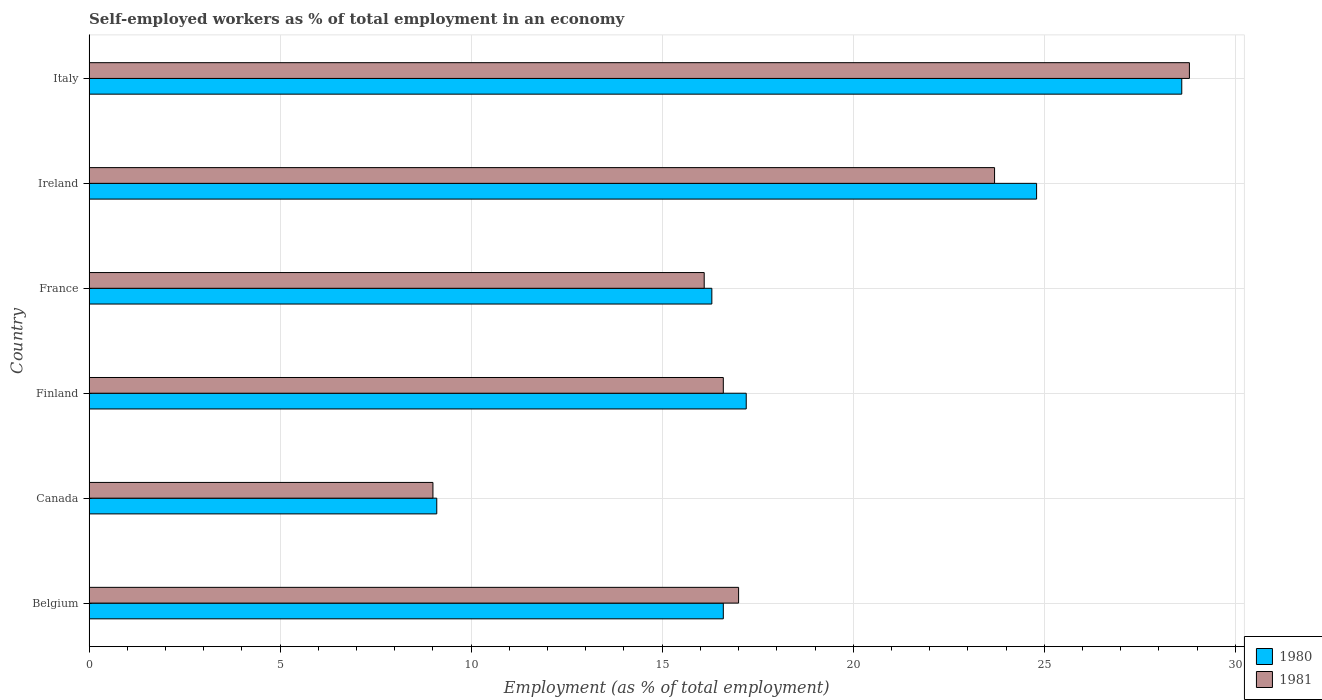How many groups of bars are there?
Give a very brief answer. 6. How many bars are there on the 6th tick from the bottom?
Ensure brevity in your answer.  2. What is the label of the 6th group of bars from the top?
Offer a very short reply. Belgium. What is the percentage of self-employed workers in 1981 in Italy?
Provide a short and direct response. 28.8. Across all countries, what is the maximum percentage of self-employed workers in 1981?
Your answer should be very brief. 28.8. Across all countries, what is the minimum percentage of self-employed workers in 1980?
Ensure brevity in your answer.  9.1. What is the total percentage of self-employed workers in 1981 in the graph?
Provide a short and direct response. 111.2. What is the difference between the percentage of self-employed workers in 1981 in Finland and that in Italy?
Your answer should be compact. -12.2. What is the difference between the percentage of self-employed workers in 1981 in Italy and the percentage of self-employed workers in 1980 in Canada?
Offer a very short reply. 19.7. What is the average percentage of self-employed workers in 1980 per country?
Keep it short and to the point. 18.77. What is the difference between the percentage of self-employed workers in 1981 and percentage of self-employed workers in 1980 in Finland?
Make the answer very short. -0.6. In how many countries, is the percentage of self-employed workers in 1980 greater than 11 %?
Offer a very short reply. 5. What is the ratio of the percentage of self-employed workers in 1981 in Finland to that in Ireland?
Offer a terse response. 0.7. Is the difference between the percentage of self-employed workers in 1981 in Belgium and Italy greater than the difference between the percentage of self-employed workers in 1980 in Belgium and Italy?
Your response must be concise. Yes. What is the difference between the highest and the second highest percentage of self-employed workers in 1981?
Provide a short and direct response. 5.1. What is the difference between the highest and the lowest percentage of self-employed workers in 1980?
Your response must be concise. 19.5. Is the sum of the percentage of self-employed workers in 1980 in Canada and France greater than the maximum percentage of self-employed workers in 1981 across all countries?
Ensure brevity in your answer.  No. What does the 1st bar from the bottom in Italy represents?
Provide a short and direct response. 1980. How many bars are there?
Keep it short and to the point. 12. Are the values on the major ticks of X-axis written in scientific E-notation?
Your response must be concise. No. Does the graph contain any zero values?
Your answer should be very brief. No. Does the graph contain grids?
Provide a succinct answer. Yes. Where does the legend appear in the graph?
Provide a short and direct response. Bottom right. How are the legend labels stacked?
Give a very brief answer. Vertical. What is the title of the graph?
Offer a terse response. Self-employed workers as % of total employment in an economy. What is the label or title of the X-axis?
Your answer should be very brief. Employment (as % of total employment). What is the Employment (as % of total employment) of 1980 in Belgium?
Offer a very short reply. 16.6. What is the Employment (as % of total employment) of 1981 in Belgium?
Make the answer very short. 17. What is the Employment (as % of total employment) of 1980 in Canada?
Your response must be concise. 9.1. What is the Employment (as % of total employment) in 1981 in Canada?
Give a very brief answer. 9. What is the Employment (as % of total employment) in 1980 in Finland?
Provide a succinct answer. 17.2. What is the Employment (as % of total employment) of 1981 in Finland?
Offer a very short reply. 16.6. What is the Employment (as % of total employment) of 1980 in France?
Your response must be concise. 16.3. What is the Employment (as % of total employment) in 1981 in France?
Your answer should be very brief. 16.1. What is the Employment (as % of total employment) of 1980 in Ireland?
Keep it short and to the point. 24.8. What is the Employment (as % of total employment) of 1981 in Ireland?
Ensure brevity in your answer.  23.7. What is the Employment (as % of total employment) in 1980 in Italy?
Provide a short and direct response. 28.6. What is the Employment (as % of total employment) in 1981 in Italy?
Ensure brevity in your answer.  28.8. Across all countries, what is the maximum Employment (as % of total employment) of 1980?
Offer a very short reply. 28.6. Across all countries, what is the maximum Employment (as % of total employment) in 1981?
Your response must be concise. 28.8. Across all countries, what is the minimum Employment (as % of total employment) of 1980?
Your answer should be very brief. 9.1. What is the total Employment (as % of total employment) in 1980 in the graph?
Provide a short and direct response. 112.6. What is the total Employment (as % of total employment) in 1981 in the graph?
Provide a short and direct response. 111.2. What is the difference between the Employment (as % of total employment) in 1980 in Belgium and that in Canada?
Make the answer very short. 7.5. What is the difference between the Employment (as % of total employment) in 1981 in Belgium and that in Canada?
Provide a succinct answer. 8. What is the difference between the Employment (as % of total employment) of 1980 in Belgium and that in Finland?
Give a very brief answer. -0.6. What is the difference between the Employment (as % of total employment) in 1980 in Belgium and that in France?
Ensure brevity in your answer.  0.3. What is the difference between the Employment (as % of total employment) in 1980 in Belgium and that in Italy?
Offer a very short reply. -12. What is the difference between the Employment (as % of total employment) of 1981 in Canada and that in France?
Make the answer very short. -7.1. What is the difference between the Employment (as % of total employment) in 1980 in Canada and that in Ireland?
Keep it short and to the point. -15.7. What is the difference between the Employment (as % of total employment) in 1981 in Canada and that in Ireland?
Your response must be concise. -14.7. What is the difference between the Employment (as % of total employment) in 1980 in Canada and that in Italy?
Provide a short and direct response. -19.5. What is the difference between the Employment (as % of total employment) of 1981 in Canada and that in Italy?
Make the answer very short. -19.8. What is the difference between the Employment (as % of total employment) of 1981 in Finland and that in France?
Offer a terse response. 0.5. What is the difference between the Employment (as % of total employment) in 1980 in Finland and that in Ireland?
Make the answer very short. -7.6. What is the difference between the Employment (as % of total employment) of 1980 in Finland and that in Italy?
Ensure brevity in your answer.  -11.4. What is the difference between the Employment (as % of total employment) in 1981 in France and that in Ireland?
Keep it short and to the point. -7.6. What is the difference between the Employment (as % of total employment) in 1980 in Ireland and that in Italy?
Ensure brevity in your answer.  -3.8. What is the difference between the Employment (as % of total employment) of 1981 in Ireland and that in Italy?
Your response must be concise. -5.1. What is the difference between the Employment (as % of total employment) of 1980 in Belgium and the Employment (as % of total employment) of 1981 in Canada?
Your answer should be very brief. 7.6. What is the difference between the Employment (as % of total employment) of 1980 in Belgium and the Employment (as % of total employment) of 1981 in Finland?
Your response must be concise. 0. What is the difference between the Employment (as % of total employment) of 1980 in Belgium and the Employment (as % of total employment) of 1981 in France?
Provide a short and direct response. 0.5. What is the difference between the Employment (as % of total employment) in 1980 in Canada and the Employment (as % of total employment) in 1981 in Ireland?
Your answer should be very brief. -14.6. What is the difference between the Employment (as % of total employment) in 1980 in Canada and the Employment (as % of total employment) in 1981 in Italy?
Ensure brevity in your answer.  -19.7. What is the difference between the Employment (as % of total employment) in 1980 in Finland and the Employment (as % of total employment) in 1981 in Ireland?
Your answer should be very brief. -6.5. What is the difference between the Employment (as % of total employment) in 1980 in Finland and the Employment (as % of total employment) in 1981 in Italy?
Your answer should be compact. -11.6. What is the difference between the Employment (as % of total employment) of 1980 in Ireland and the Employment (as % of total employment) of 1981 in Italy?
Provide a succinct answer. -4. What is the average Employment (as % of total employment) in 1980 per country?
Ensure brevity in your answer.  18.77. What is the average Employment (as % of total employment) of 1981 per country?
Keep it short and to the point. 18.53. What is the difference between the Employment (as % of total employment) in 1980 and Employment (as % of total employment) in 1981 in Belgium?
Your answer should be very brief. -0.4. What is the difference between the Employment (as % of total employment) in 1980 and Employment (as % of total employment) in 1981 in Finland?
Your answer should be very brief. 0.6. What is the difference between the Employment (as % of total employment) in 1980 and Employment (as % of total employment) in 1981 in France?
Your answer should be compact. 0.2. What is the ratio of the Employment (as % of total employment) of 1980 in Belgium to that in Canada?
Your answer should be very brief. 1.82. What is the ratio of the Employment (as % of total employment) of 1981 in Belgium to that in Canada?
Your response must be concise. 1.89. What is the ratio of the Employment (as % of total employment) of 1980 in Belgium to that in Finland?
Offer a terse response. 0.97. What is the ratio of the Employment (as % of total employment) of 1981 in Belgium to that in Finland?
Offer a very short reply. 1.02. What is the ratio of the Employment (as % of total employment) of 1980 in Belgium to that in France?
Provide a short and direct response. 1.02. What is the ratio of the Employment (as % of total employment) in 1981 in Belgium to that in France?
Your answer should be very brief. 1.06. What is the ratio of the Employment (as % of total employment) in 1980 in Belgium to that in Ireland?
Your response must be concise. 0.67. What is the ratio of the Employment (as % of total employment) in 1981 in Belgium to that in Ireland?
Ensure brevity in your answer.  0.72. What is the ratio of the Employment (as % of total employment) in 1980 in Belgium to that in Italy?
Provide a succinct answer. 0.58. What is the ratio of the Employment (as % of total employment) of 1981 in Belgium to that in Italy?
Ensure brevity in your answer.  0.59. What is the ratio of the Employment (as % of total employment) of 1980 in Canada to that in Finland?
Keep it short and to the point. 0.53. What is the ratio of the Employment (as % of total employment) of 1981 in Canada to that in Finland?
Provide a succinct answer. 0.54. What is the ratio of the Employment (as % of total employment) in 1980 in Canada to that in France?
Make the answer very short. 0.56. What is the ratio of the Employment (as % of total employment) in 1981 in Canada to that in France?
Your answer should be very brief. 0.56. What is the ratio of the Employment (as % of total employment) in 1980 in Canada to that in Ireland?
Provide a short and direct response. 0.37. What is the ratio of the Employment (as % of total employment) in 1981 in Canada to that in Ireland?
Your answer should be compact. 0.38. What is the ratio of the Employment (as % of total employment) in 1980 in Canada to that in Italy?
Your response must be concise. 0.32. What is the ratio of the Employment (as % of total employment) in 1981 in Canada to that in Italy?
Provide a short and direct response. 0.31. What is the ratio of the Employment (as % of total employment) of 1980 in Finland to that in France?
Give a very brief answer. 1.06. What is the ratio of the Employment (as % of total employment) of 1981 in Finland to that in France?
Provide a succinct answer. 1.03. What is the ratio of the Employment (as % of total employment) of 1980 in Finland to that in Ireland?
Your answer should be compact. 0.69. What is the ratio of the Employment (as % of total employment) in 1981 in Finland to that in Ireland?
Ensure brevity in your answer.  0.7. What is the ratio of the Employment (as % of total employment) of 1980 in Finland to that in Italy?
Make the answer very short. 0.6. What is the ratio of the Employment (as % of total employment) of 1981 in Finland to that in Italy?
Your response must be concise. 0.58. What is the ratio of the Employment (as % of total employment) of 1980 in France to that in Ireland?
Offer a very short reply. 0.66. What is the ratio of the Employment (as % of total employment) in 1981 in France to that in Ireland?
Give a very brief answer. 0.68. What is the ratio of the Employment (as % of total employment) in 1980 in France to that in Italy?
Keep it short and to the point. 0.57. What is the ratio of the Employment (as % of total employment) of 1981 in France to that in Italy?
Make the answer very short. 0.56. What is the ratio of the Employment (as % of total employment) of 1980 in Ireland to that in Italy?
Offer a very short reply. 0.87. What is the ratio of the Employment (as % of total employment) in 1981 in Ireland to that in Italy?
Your response must be concise. 0.82. What is the difference between the highest and the second highest Employment (as % of total employment) of 1981?
Provide a short and direct response. 5.1. What is the difference between the highest and the lowest Employment (as % of total employment) in 1981?
Provide a succinct answer. 19.8. 